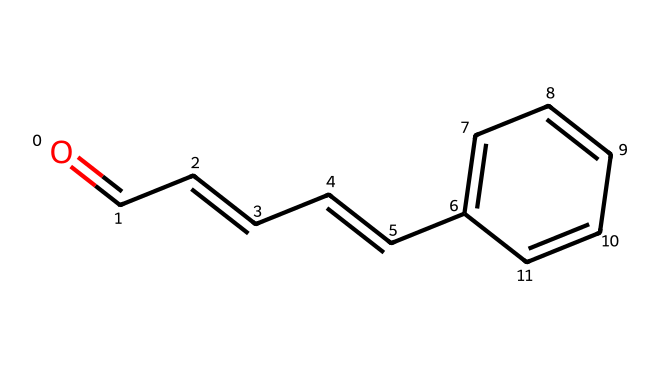What is the molecular formula of cinnamaldehyde? To determine the molecular formula, we need to count the number of each type of atom present in the SMILES representation. Parsing the SMILES, we identify the following: 9 carbon (C) atoms, 8 hydrogen (H) atoms, and 1 oxygen (O) atom. Therefore, the molecular formula is C9H8O.
Answer: C9H8O How many double bonds are present in cinnamaldehyde? By analyzing the structure derived from the SMILES, we can see that there are two double bonds present: one between the carbonyl carbon and oxygen (C=O) and one in the carbon chain (C=C). In total, this gives us 2 double bonds.
Answer: 2 What functional group characterizes this aldehyde? The characteristic functional group of aldehydes is the formyl group, which is -CHO. In the structure of cinnamaldehyde, we see the presence of this -CHO group at one end of the molecule.
Answer: -CHO How many rings are present in the structure of cinnamaldehyde? Upon examining the SMILES structure, it is clear that there are no cyclic components since all carbon atoms are part of a linear or branched chain. Therefore, the count of rings is zero.
Answer: 0 Which physical property does the presence of the aldehyde group contribute to cinnamaldehyde? The aldehyde group (-CHO) contributes significantly to the chemical's reactivity and volatility, which can influence its aroma and taste profile in wines. This is a key reason for its flavor profile.
Answer: reactivity What type of isomerism is shown in cinnamaldehyde compared to other aldehydes? Cinnamaldehyde exhibits geometric (cis-trans) isomerism due to the presence of double bonds in its structure that can lead to different spatial arrangements. However, because of a restriction in rotation, it can exhibit specific isomers that differ in physical and chemical properties.
Answer: geometric isomerism 